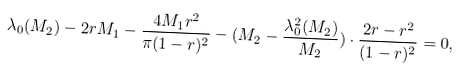<formula> <loc_0><loc_0><loc_500><loc_500>\lambda _ { 0 } ( M _ { 2 } ) - 2 r M _ { 1 } - \frac { 4 M _ { 1 } r ^ { 2 } } { \pi ( 1 - r ) ^ { 2 } } - ( M _ { 2 } - \frac { \lambda _ { 0 } ^ { 2 } ( M _ { 2 } ) } { M _ { 2 } } ) \cdot \frac { 2 r - r ^ { 2 } } { ( 1 - r ) ^ { 2 } } = 0 ,</formula> 